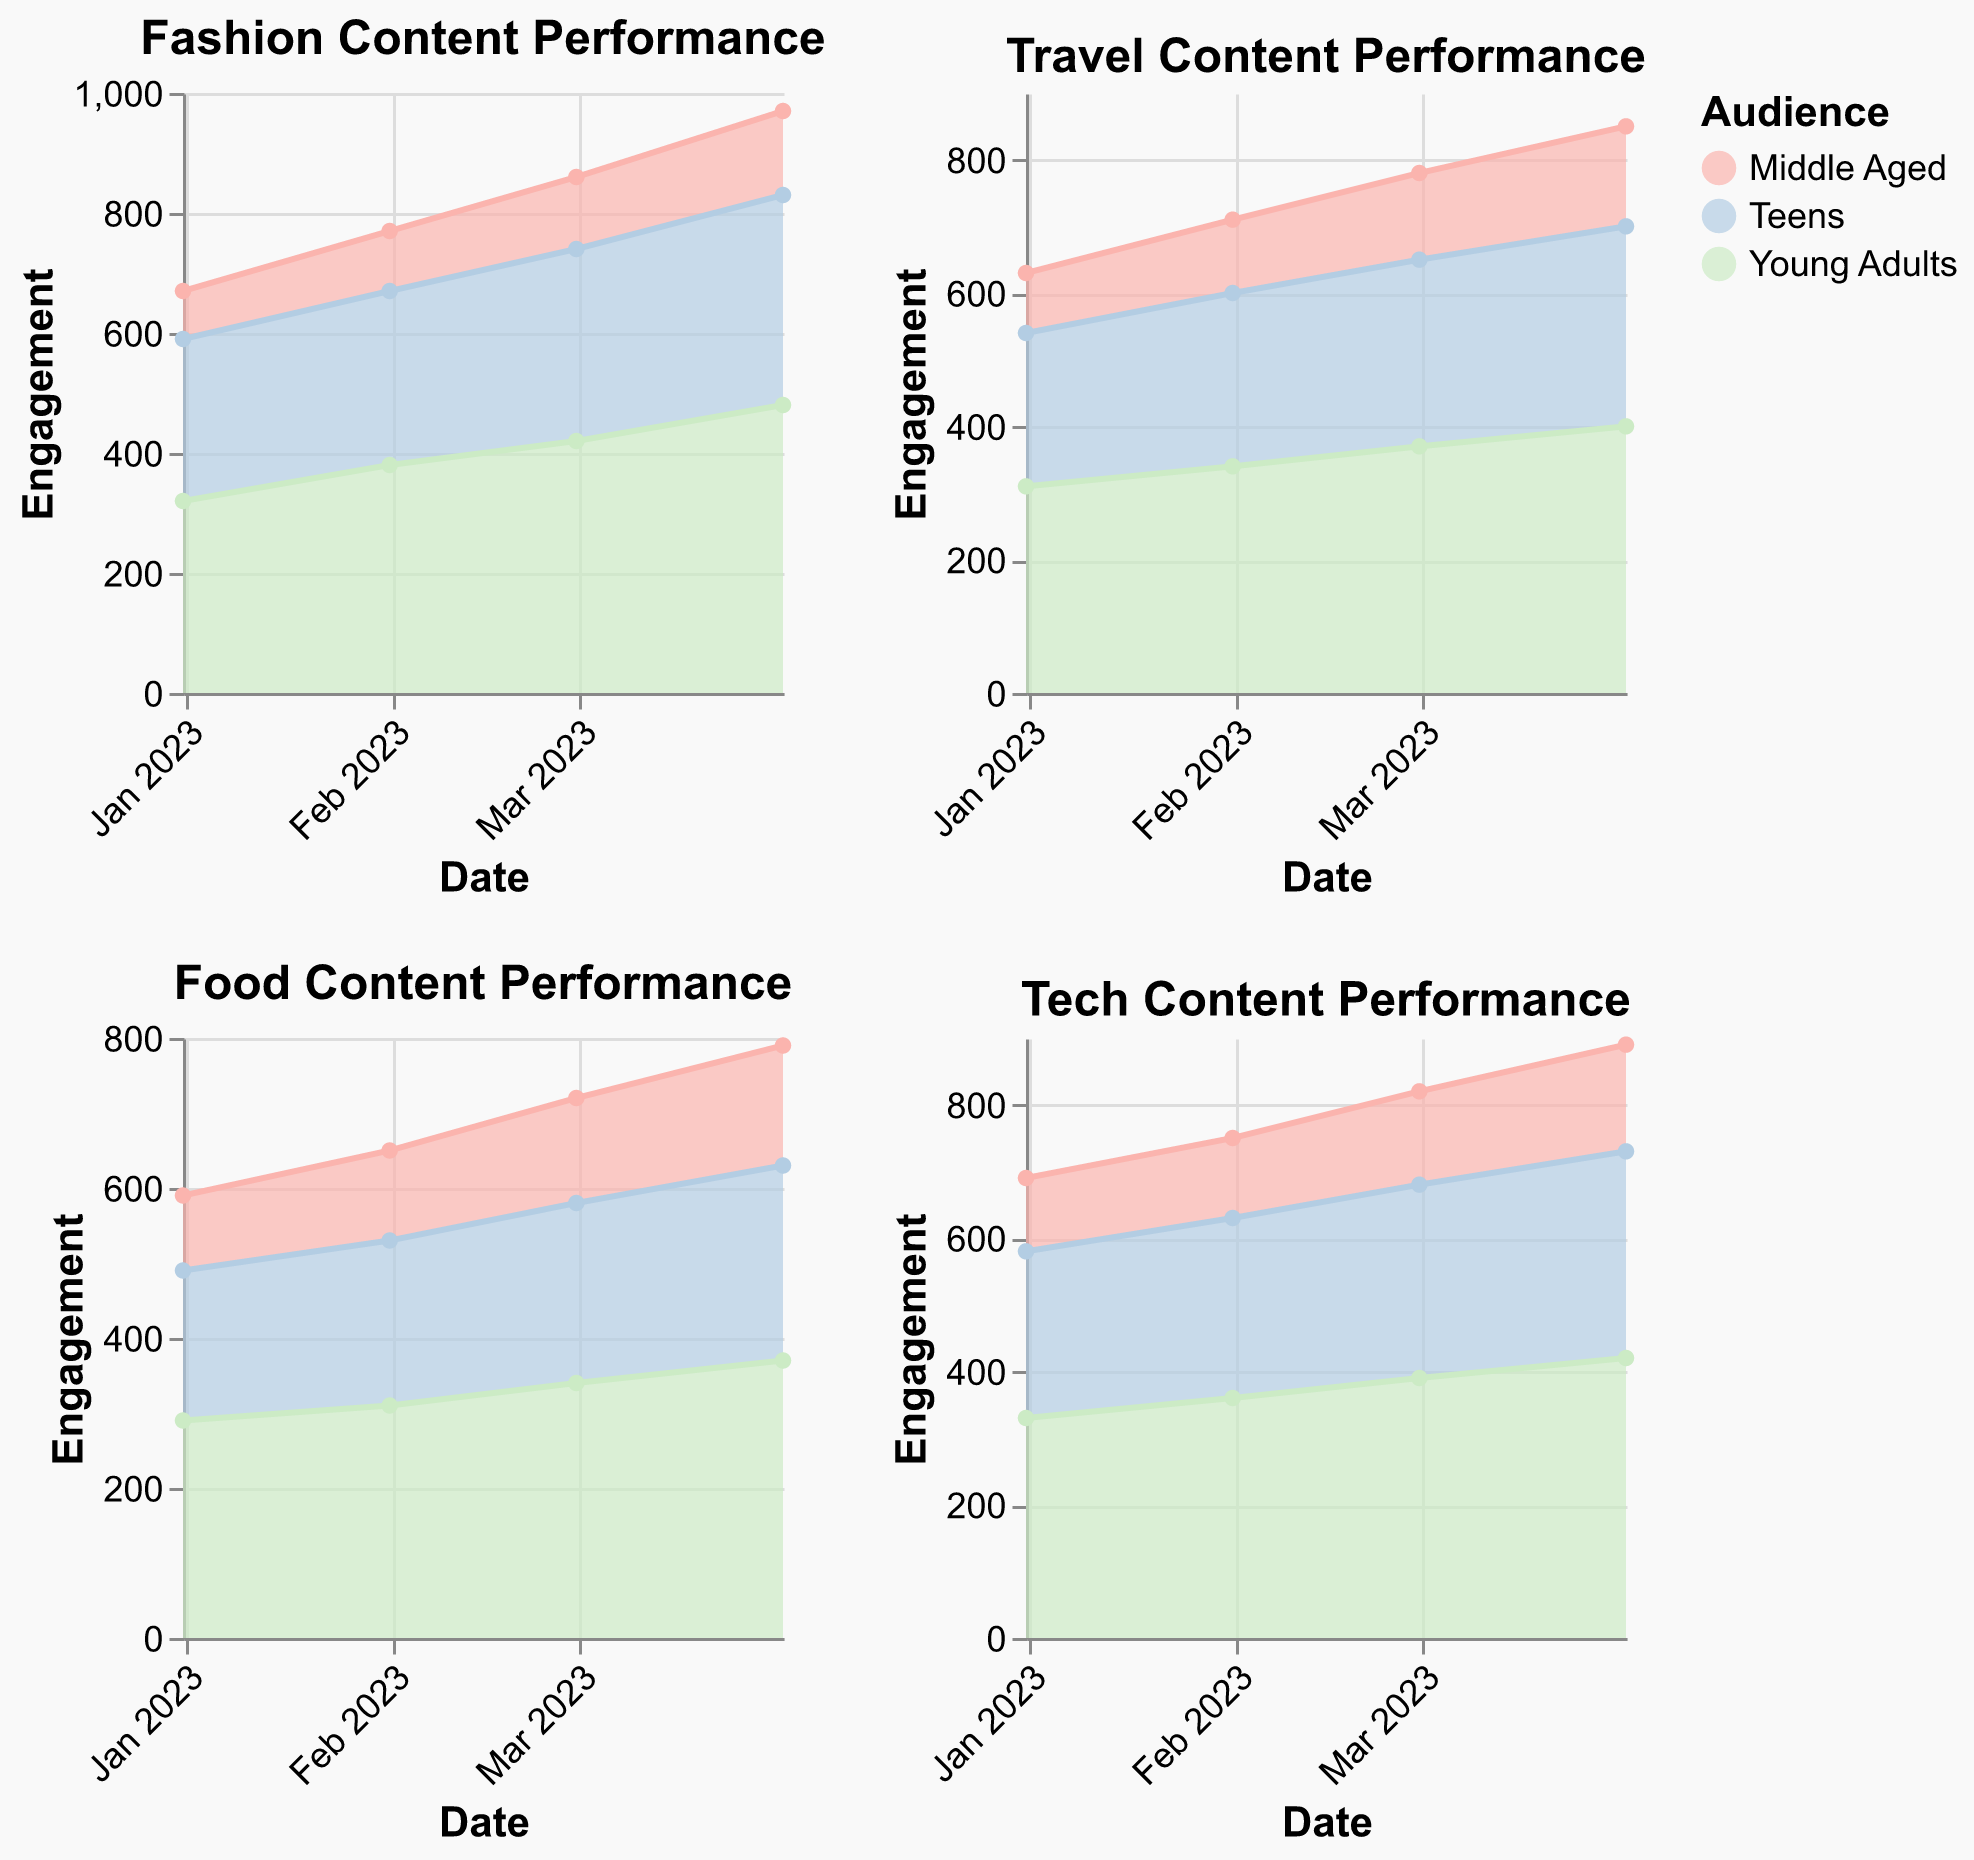What is the title of the subplot focused on fashion content? The title of each subplot is clearly displayed at the top. Look at the subplot dedicated to fashion content to find its title.
Answer: Fashion Content Performance Which age group has the highest engagement for Tech content in April 2023? In the Tech content subplot, locate the data points for April 2023 and compare the engagement values for each age group.
Answer: Young Adults How did engagement for young adults in Food content change from January 2023 to April 2023? Note the engagement values for Young Adults in the Food content subplot from January 2023 to April 2023. Subtract the January value from the April value.
Answer: Increased by 80 (290 to 370) Compare the follower growth of Teens in Fashion content to Tech content in February 2023. Find the follower growth values for Teens in both Fashion and Tech content subplots for February 2023, and compare them.
Answer: Equal (both 150) Between Travel and Food content, which one had higher overall engagement for Middle Aged audience in March 2023? Find the engagement values for the Middle Aged audience in March 2023 for both Travel and Food content. Compare these values.
Answer: Food (140 vs 130) What is the overall trend in engagement for Teens in Fashion content from January to April 2023? Observe the engagement values for Teens in the Fashion content subplot across the months from January to April 2023. Determine whether the values are increasing, decreasing, or stable.
Answer: Increasing Which type of content shows the highest engagement for Young Adults in April 2023? Look at the engagement values for Young Adults across all content types in April 2023 and identify the highest one.
Answer: Fashion (480) By how much did the engagement of middle-aged audience in Travel content increase from January to April 2023? Note the engagement values for Middle Aged audience in Travel content for January and April 2023. Subtract the January value from the April value.
Answer: Increased by 60 (90 to 150) What is the primary color scheme used for the Travel content performance subplot? Each subplot uses a unique color scheme. Observe the colors in the Travel content subplot to identify the dominant color scheme.
Answer: Pastel2 